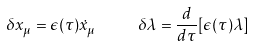<formula> <loc_0><loc_0><loc_500><loc_500>\delta x _ { \mu } = \epsilon ( \tau ) \dot { x } _ { \mu } \text { \quad } \delta \lambda = \frac { d } { d \tau } [ \epsilon ( \tau ) \lambda ]</formula> 